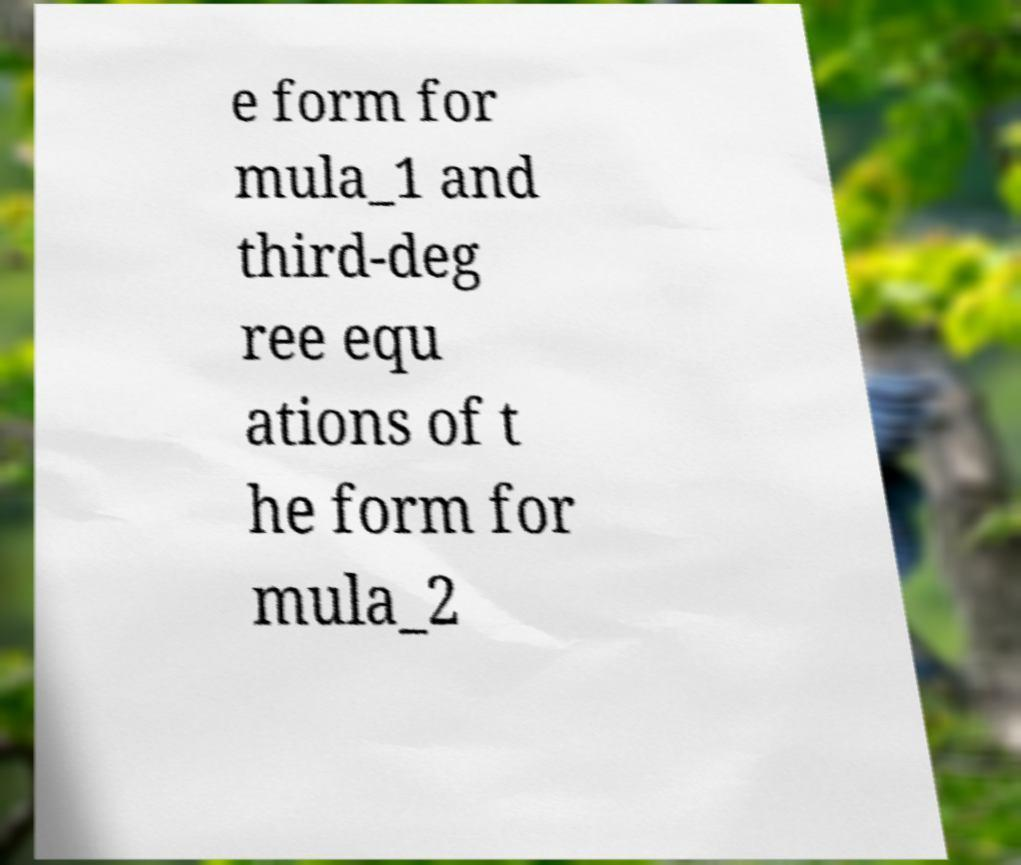What messages or text are displayed in this image? I need them in a readable, typed format. e form for mula_1 and third-deg ree equ ations of t he form for mula_2 